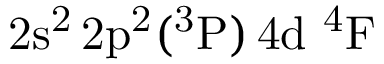<formula> <loc_0><loc_0><loc_500><loc_500>2 s ^ { 2 } \, 2 p ^ { 2 } ( ^ { 3 } P ) \, 4 d ^ { 4 } F</formula> 